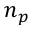Convert formula to latex. <formula><loc_0><loc_0><loc_500><loc_500>n _ { p }</formula> 